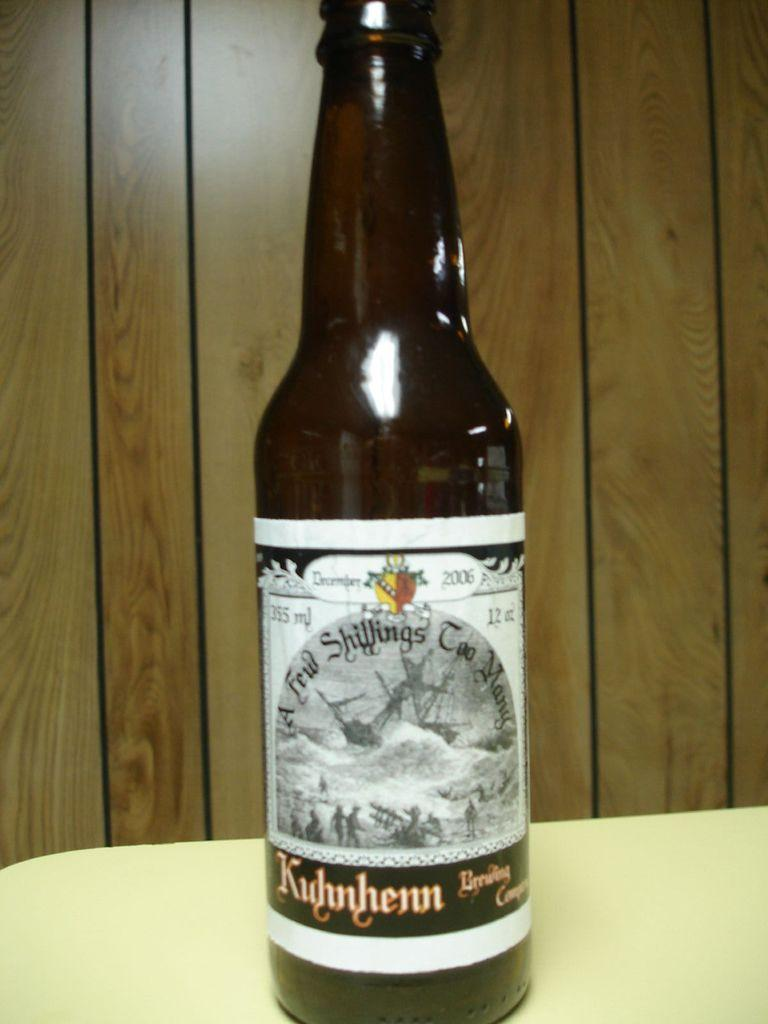<image>
Write a terse but informative summary of the picture. a bottle of ale with a few shillings too many written on it 